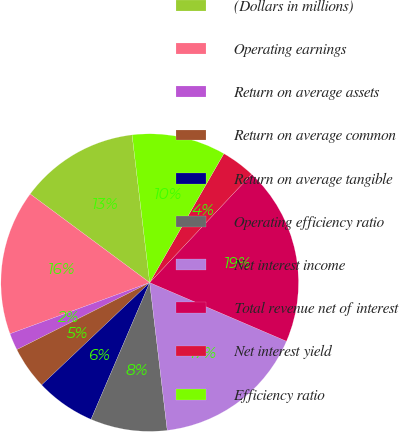<chart> <loc_0><loc_0><loc_500><loc_500><pie_chart><fcel>(Dollars in millions)<fcel>Operating earnings<fcel>Return on average assets<fcel>Return on average common<fcel>Return on average tangible<fcel>Operating efficiency ratio<fcel>Net interest income<fcel>Total revenue net of interest<fcel>Net interest yield<fcel>Efficiency ratio<nl><fcel>12.96%<fcel>15.74%<fcel>1.85%<fcel>4.63%<fcel>6.48%<fcel>8.33%<fcel>16.67%<fcel>19.44%<fcel>3.7%<fcel>10.19%<nl></chart> 